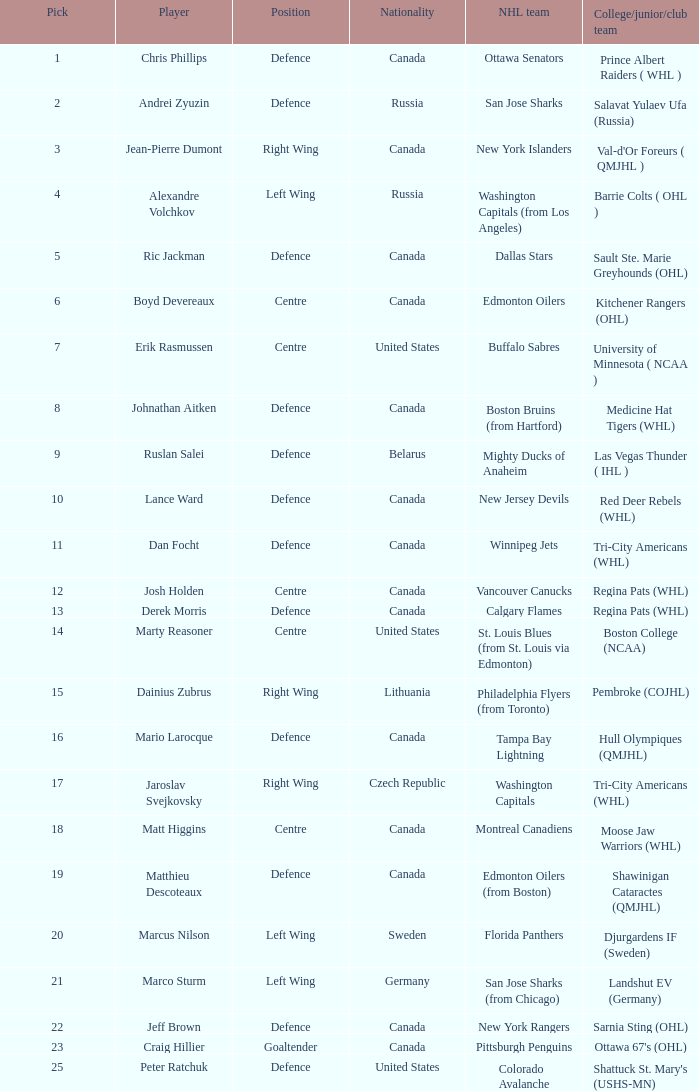How many spots does the draft pick from czech republic play? 1.0. 